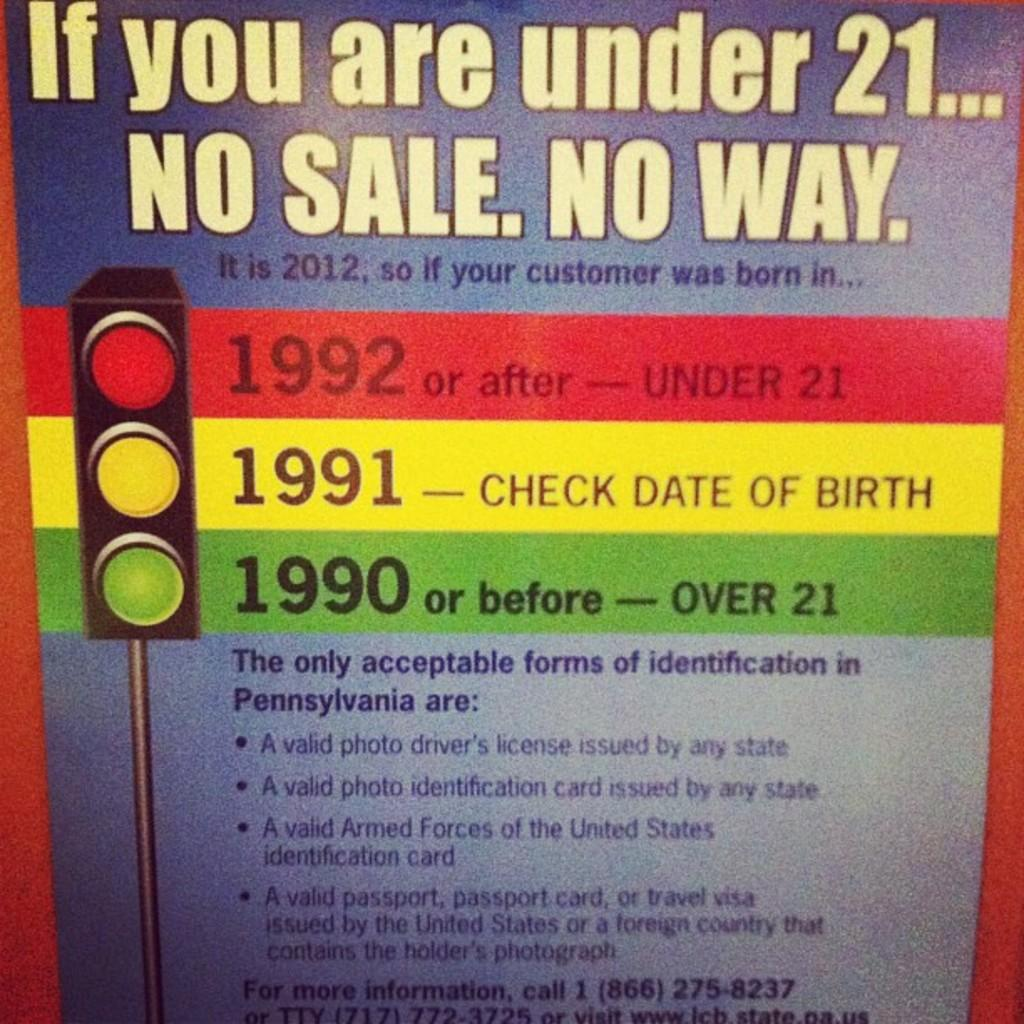<image>
Render a clear and concise summary of the photo. a sign that says 'if you are under 21... no sale. no way.' on it 